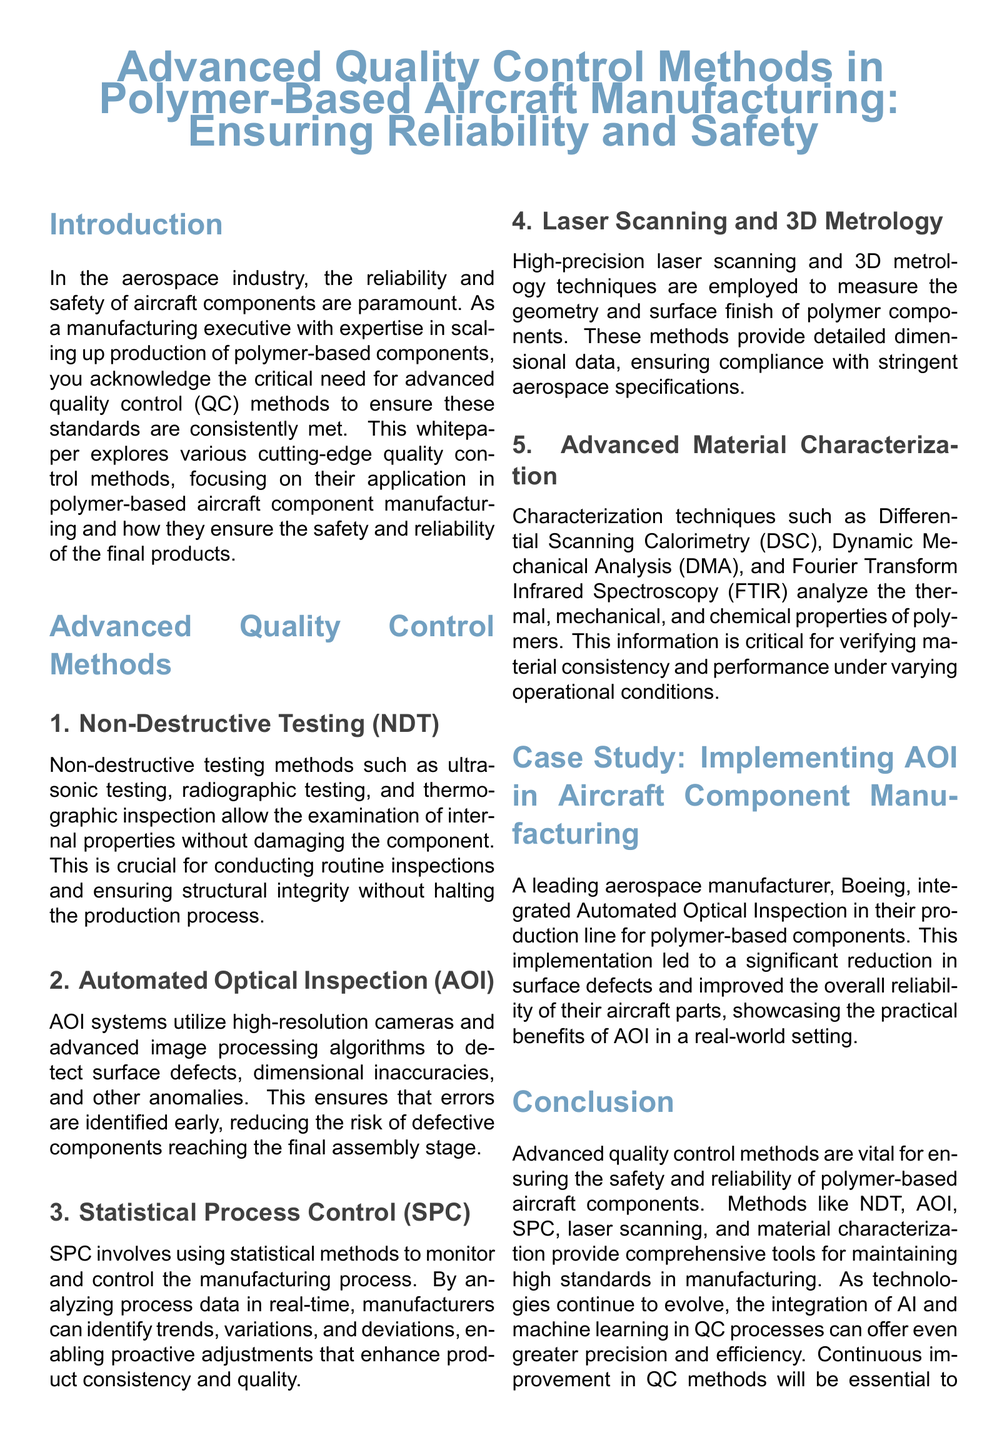What is the primary focus of the whitepaper? The primary focus is on advanced quality control methods in polymer-based aircraft manufacturing.
Answer: Advanced quality control methods in polymer-based aircraft manufacturing What does NDT stand for in the document? NDT stands for Non-Destructive Testing, a method discussed in the whitepaper.
Answer: Non-Destructive Testing Which company is mentioned in the case study? The case study highlights the implementation of AOI by Boeing, a leading aerospace manufacturer.
Answer: Boeing What method is used for surface defect detection? The method used for detecting surface defects is Automated Optical Inspection.
Answer: Automated Optical Inspection What is one technique used for material characterization? Differential Scanning Calorimetry is mentioned as one technique for material characterization.
Answer: Differential Scanning Calorimetry How does Statistical Process Control help manufacturers? Statistical Process Control helps manufacturers by monitoring and controlling the manufacturing process using statistical methods.
Answer: Monitoring and controlling the manufacturing process Which quality control method involves high-precision measurement techniques? High-precision measurement techniques are described under laser scanning and 3D metrology.
Answer: Laser scanning and 3D metrology What is emphasized as essential for the aerospace industry in the conclusion? In the conclusion, continuous improvement in quality control methods is emphasized as essential for the aerospace industry.
Answer: Continuous improvement in quality control methods 